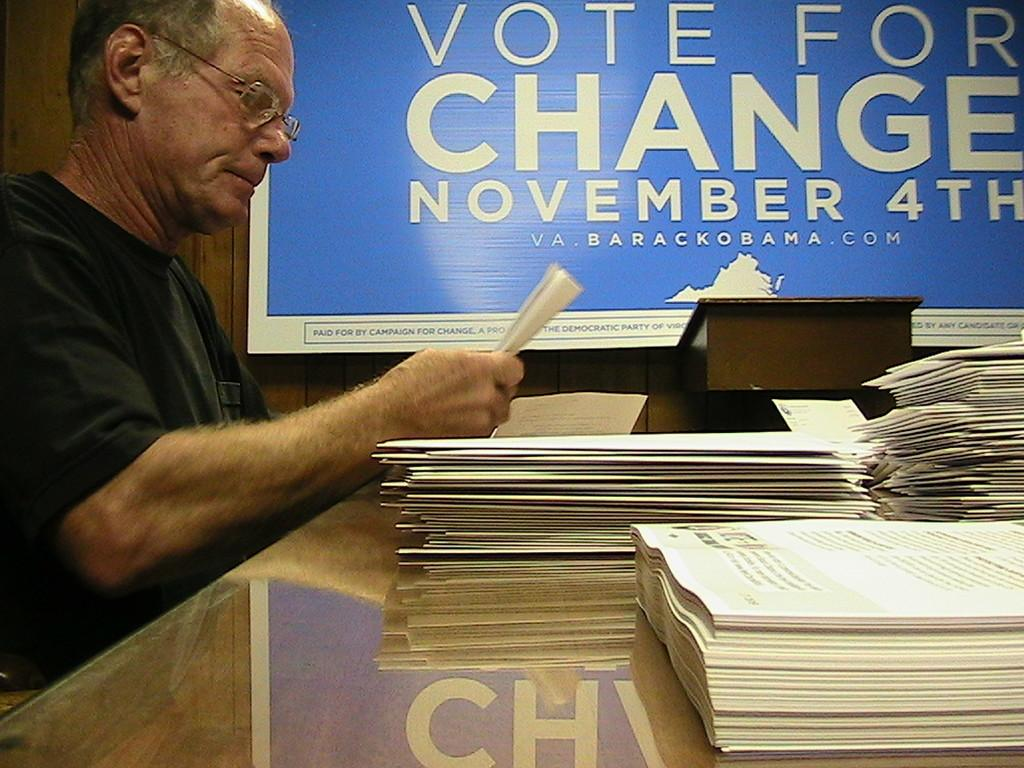<image>
Share a concise interpretation of the image provided. A man looks at papers in front of a Vote for Change sign. 